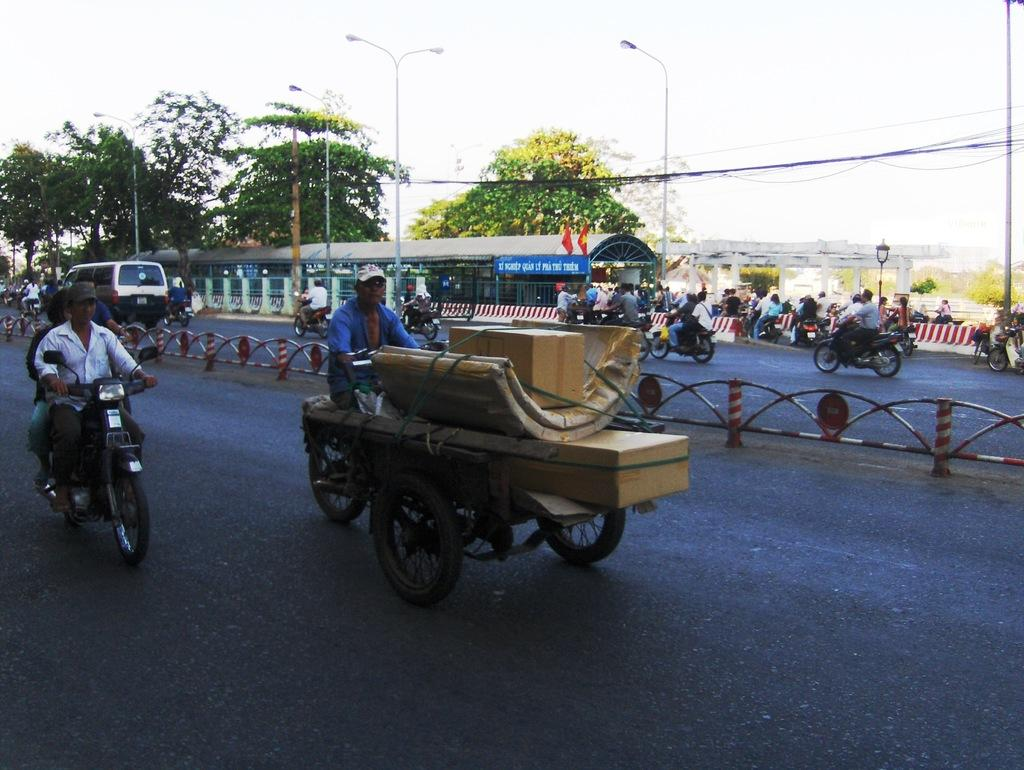What is the main subject in the image? There is a cart in the image. What are the people in the image doing? People are riding motorcycles in the image. Can you describe the vehicle on the road? There is a vehicle on the road in the image. What can be seen in the background of the image? In the background of the image, there is a shelter, fences, a bridge, streetlights, and the sky. What type of watch is the person wearing while leading the mitten across the bridge? There is no person wearing a watch or leading a mitten across the bridge in the image. 